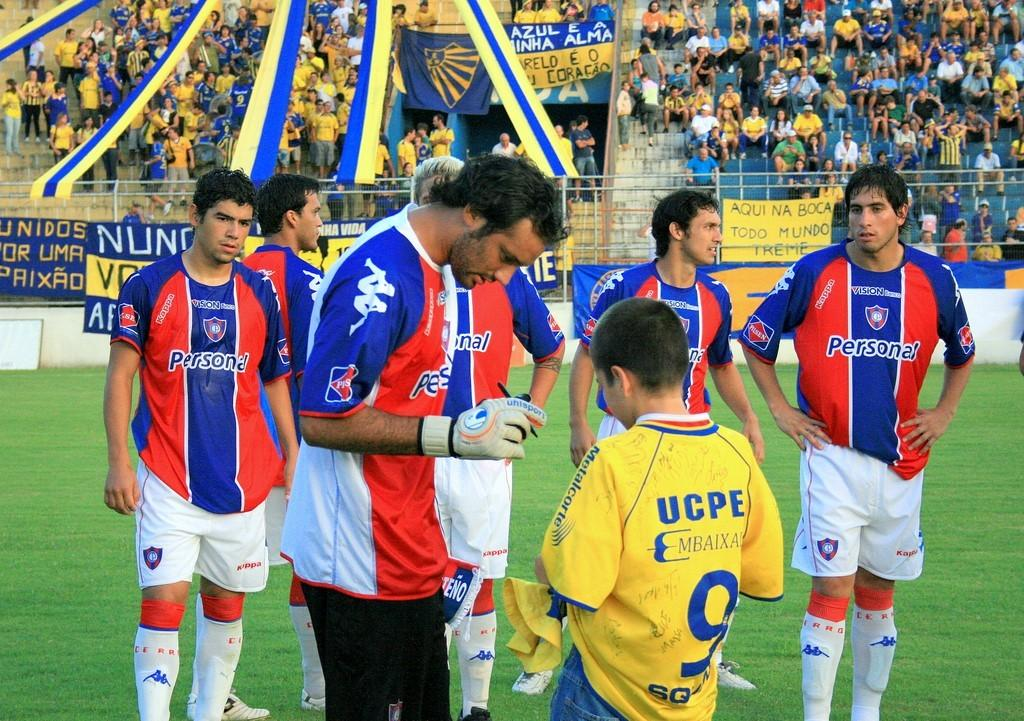What is happening in the image? There is a group of persons standing on the ground. What can be seen at the bottom of the image? The ground is visible at the bottom of the image. What is located in the background of the image? There is a fence in the background of the image. Can you describe the ground in the image? The ground is visible in the background of the image. What type of zinc is being used to build the train in the image? There is no train present in the image, so it is not possible to determine what type of zinc might be used in its construction. 